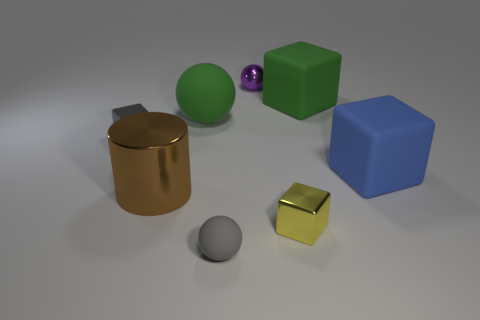Add 1 tiny yellow rubber cylinders. How many objects exist? 9 Subtract all small yellow blocks. How many blocks are left? 3 Subtract all green spheres. How many spheres are left? 2 Add 1 green balls. How many green balls are left? 2 Add 2 small gray matte cylinders. How many small gray matte cylinders exist? 2 Subtract 0 green cylinders. How many objects are left? 8 Subtract all cylinders. How many objects are left? 7 Subtract all red spheres. Subtract all yellow cubes. How many spheres are left? 3 Subtract all green cylinders. How many yellow balls are left? 0 Subtract all small matte things. Subtract all tiny metallic balls. How many objects are left? 6 